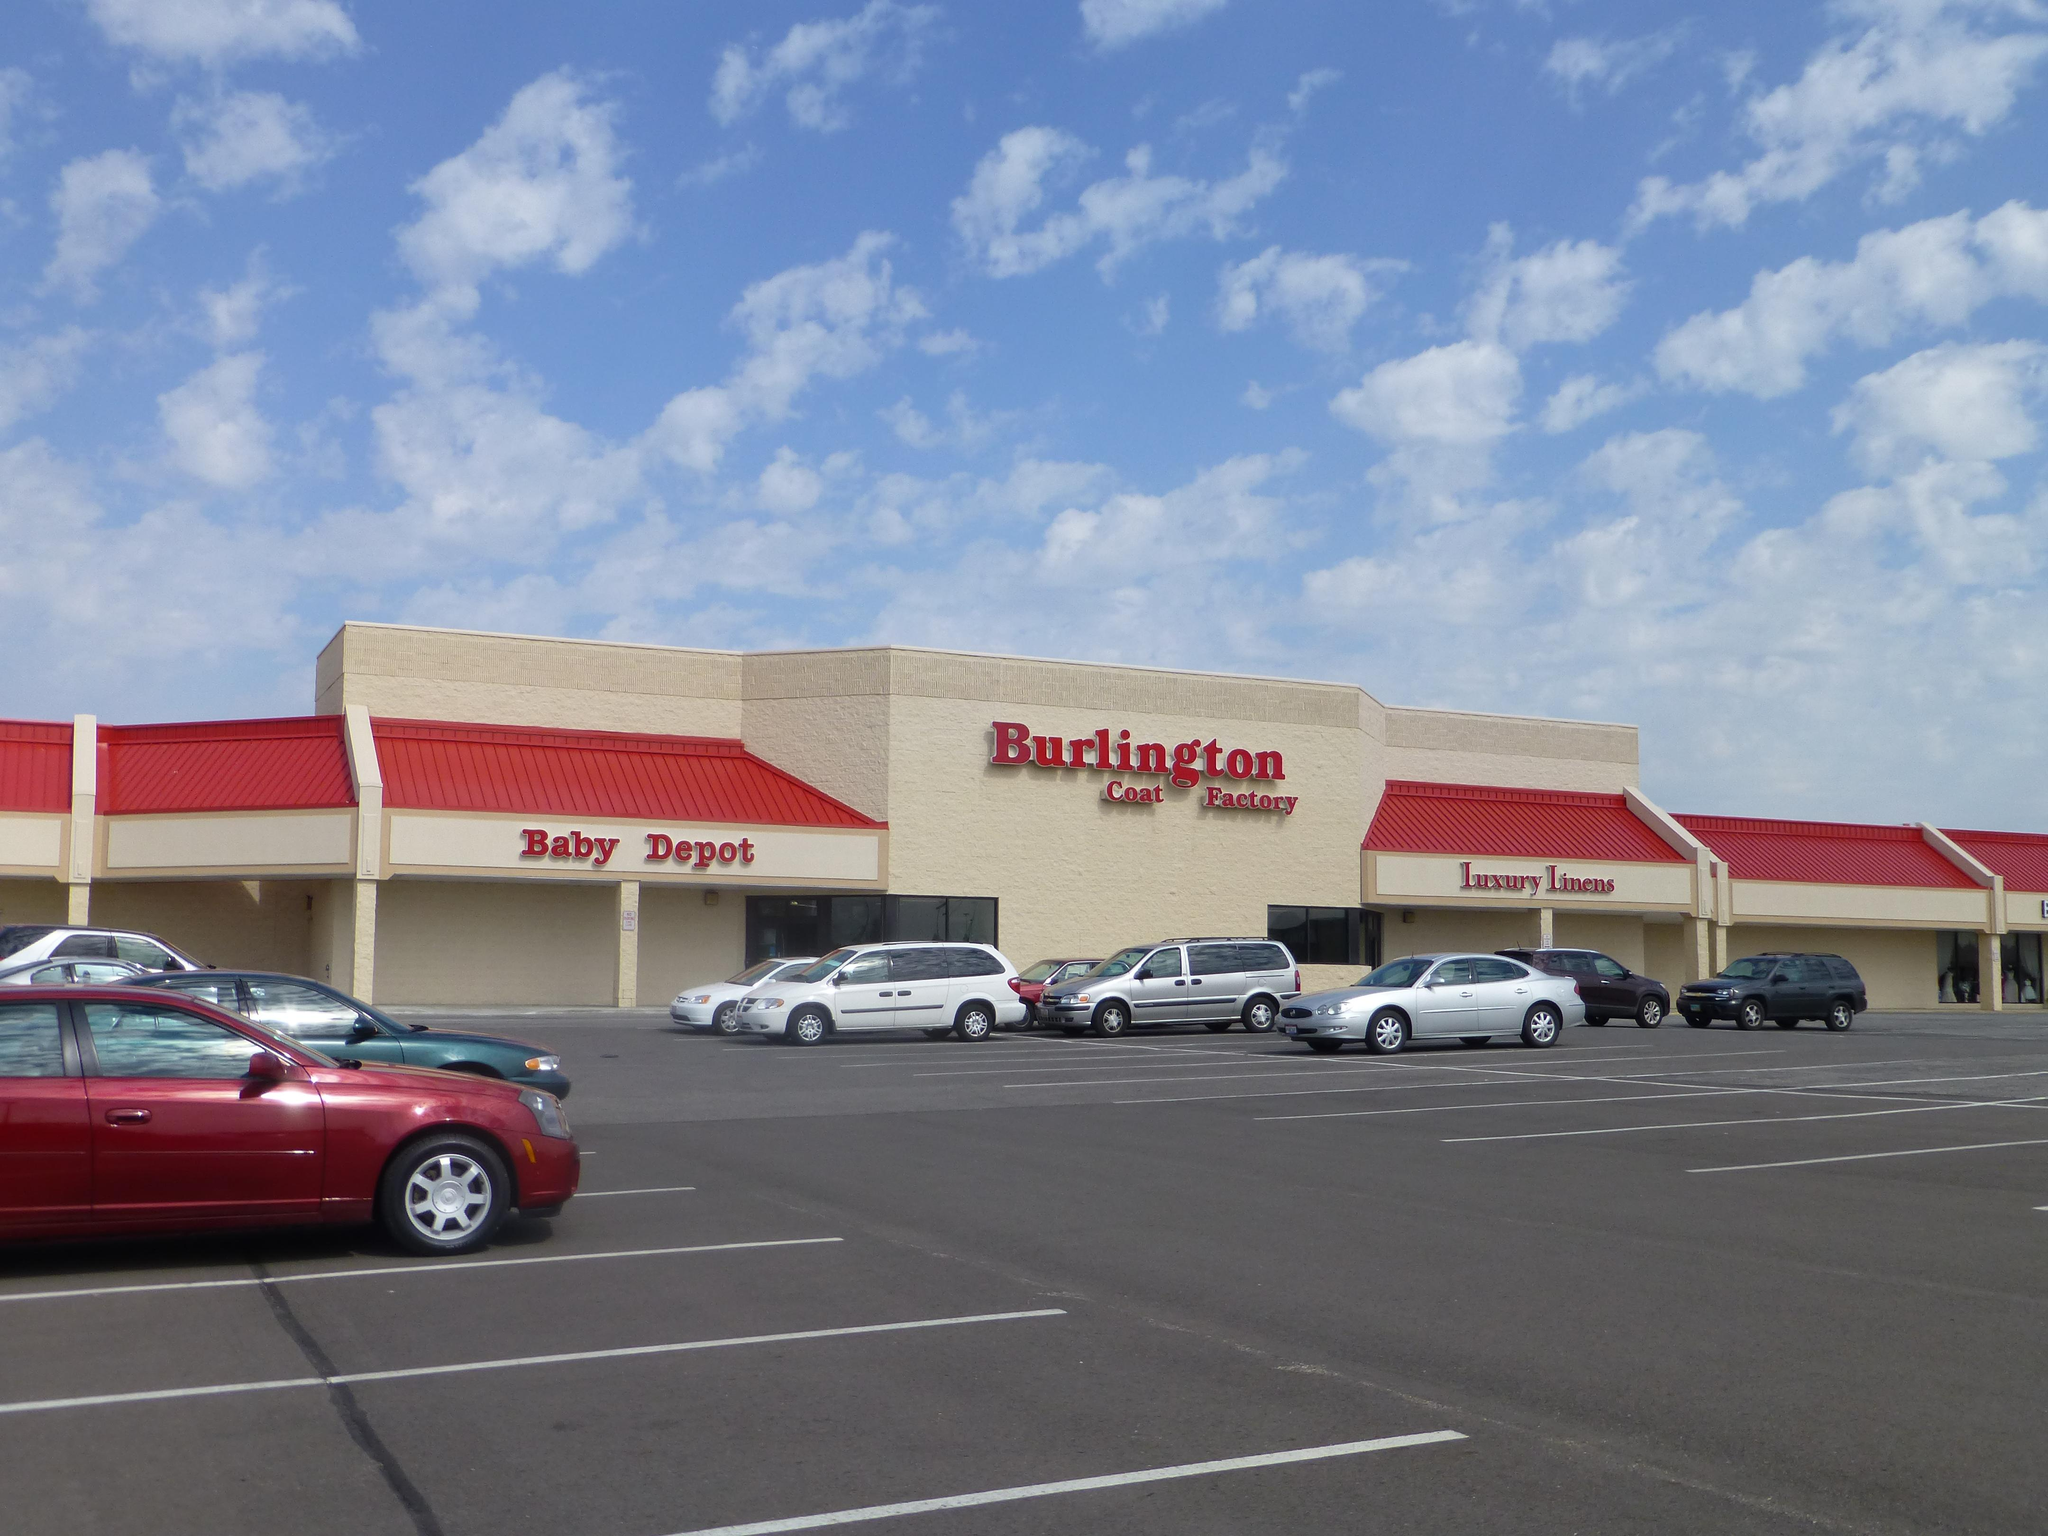What is the main subject of the image? The main subject of the image is a building with text. What else can be seen in the image besides the building? Vehicles are parked on the road in front of the building. What is visible in the background of the image? The sky is visible in the background of the image. How would you describe the sky in the image? The sky appears to be cloudy. Is there a veil covering the building in the image? No, there is no veil covering the building in the image. What time of day is depicted in the image? The provided facts do not specify the time of day, so it cannot be determined from the image. 